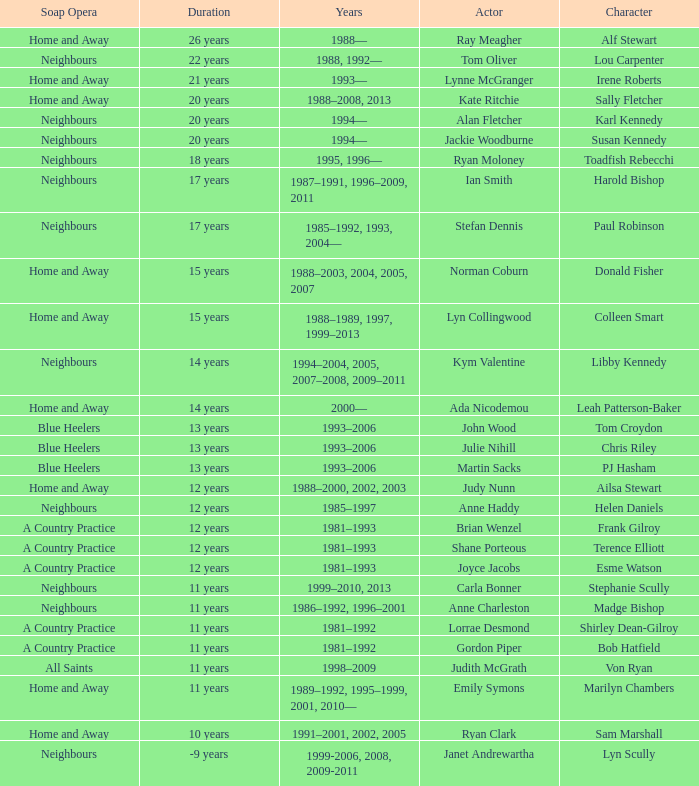What character was portrayed by the same actor for 12 years on Neighbours? Helen Daniels. 